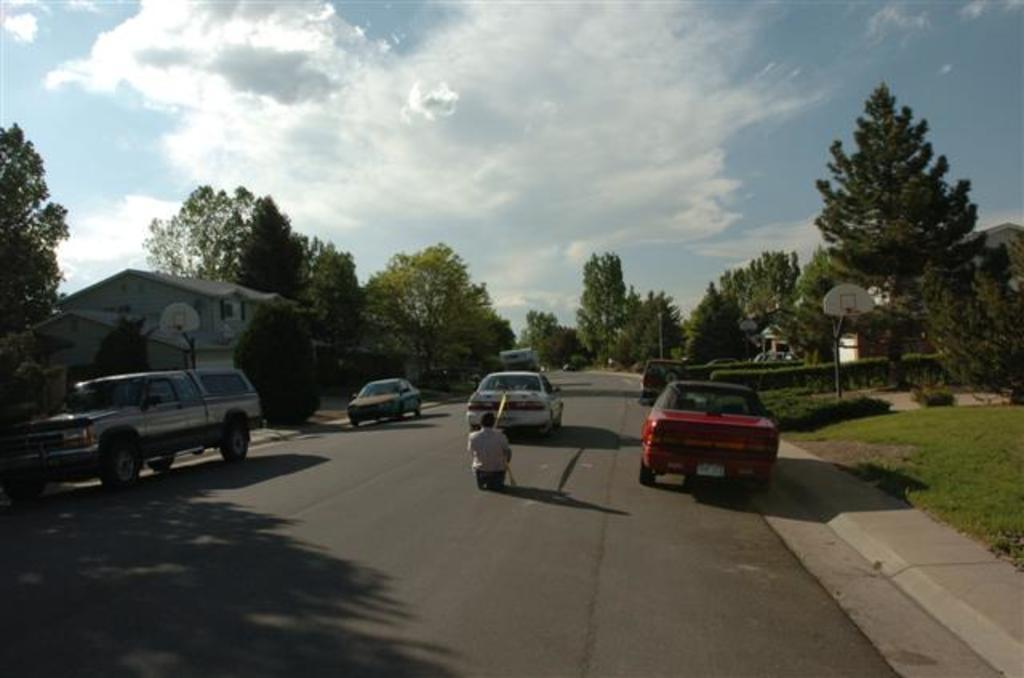What is the main feature of the image? There is a road in the image. What can be seen on the road? There are vehicles and persons on the road. What type of vegetation is present beside the road? There are trees and bushes beside the road. What is visible at the top of the image? The sky is visible at the top of the image. What type of wealth is displayed by the duck in the image? There is no duck present in the image, so it is not possible to determine any wealth displayed by a duck. Can you describe the smile on the person's face in the image? The provided facts do not mention any specific expressions or emotions of the persons in the image, so it is not possible to describe a smile. 